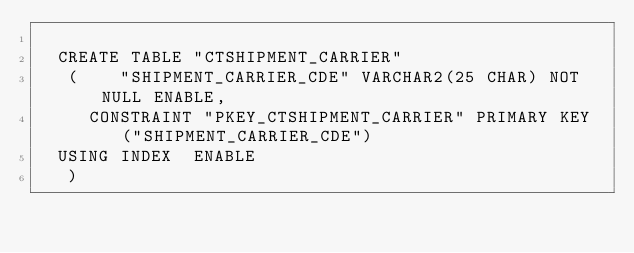Convert code to text. <code><loc_0><loc_0><loc_500><loc_500><_SQL_>
  CREATE TABLE "CTSHIPMENT_CARRIER" 
   (	"SHIPMENT_CARRIER_CDE" VARCHAR2(25 CHAR) NOT NULL ENABLE, 
	 CONSTRAINT "PKEY_CTSHIPMENT_CARRIER" PRIMARY KEY ("SHIPMENT_CARRIER_CDE")
  USING INDEX  ENABLE
   ) </code> 